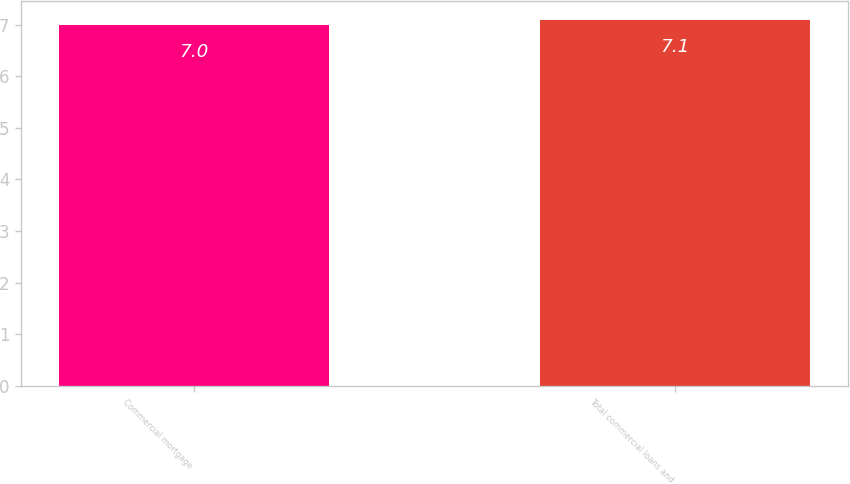<chart> <loc_0><loc_0><loc_500><loc_500><bar_chart><fcel>Commercial mortgage<fcel>Total commercial loans and<nl><fcel>7<fcel>7.1<nl></chart> 